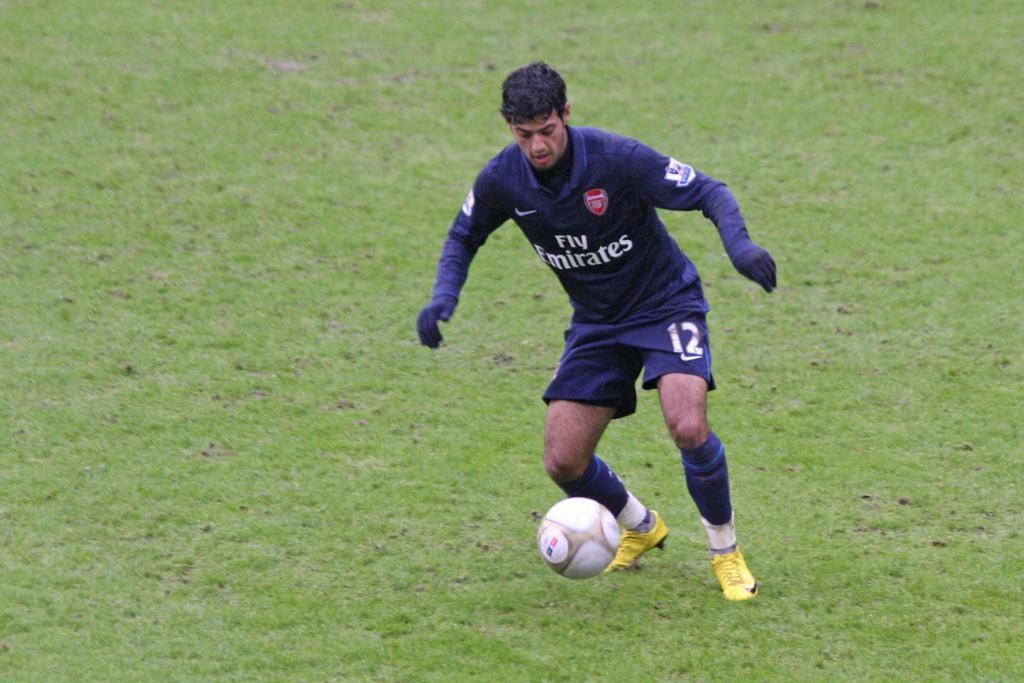Can you describe this image briefly? In this picture we can see a man playing with a football in a grass. He is wearing shirt with full length sleeves and gloves which are in blue colour. 